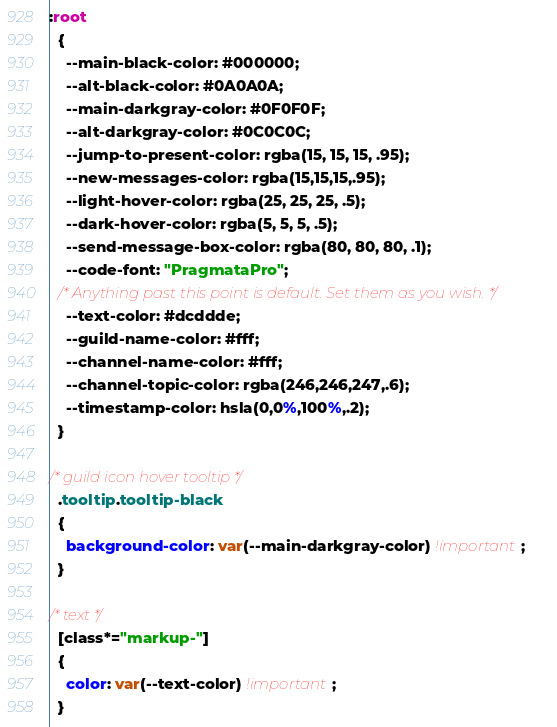<code> <loc_0><loc_0><loc_500><loc_500><_CSS_>:root
  {
    --main-black-color: #000000;
    --alt-black-color: #0A0A0A;
    --main-darkgray-color: #0F0F0F;
    --alt-darkgray-color: #0C0C0C;
    --jump-to-present-color: rgba(15, 15, 15, .95);
    --new-messages-color: rgba(15,15,15,.95);
    --light-hover-color: rgba(25, 25, 25, .5);
    --dark-hover-color: rgba(5, 5, 5, .5);
    --send-message-box-color: rgba(80, 80, 80, .1);
    --code-font: "PragmataPro";
  /* Anything past this point is default. Set them as you wish. */
    --text-color: #dcddde;
    --guild-name-color: #fff;
    --channel-name-color: #fff;
    --channel-topic-color: rgba(246,246,247,.6);
    --timestamp-color: hsla(0,0%,100%,.2);
  }

/* guild icon hover tooltip */
  .tooltip.tooltip-black
  {
    background-color: var(--main-darkgray-color) !important;
  }

/* text */
  [class*="markup-"]
  {
    color: var(--text-color) !important;
  }
</code> 